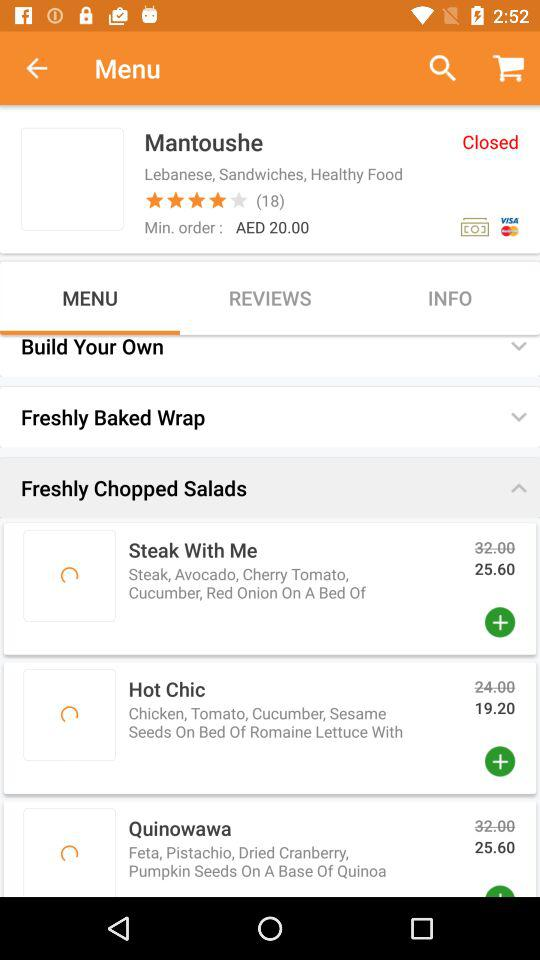What is the minimum order amount?
Answer the question using a single word or phrase. AED 20.00 